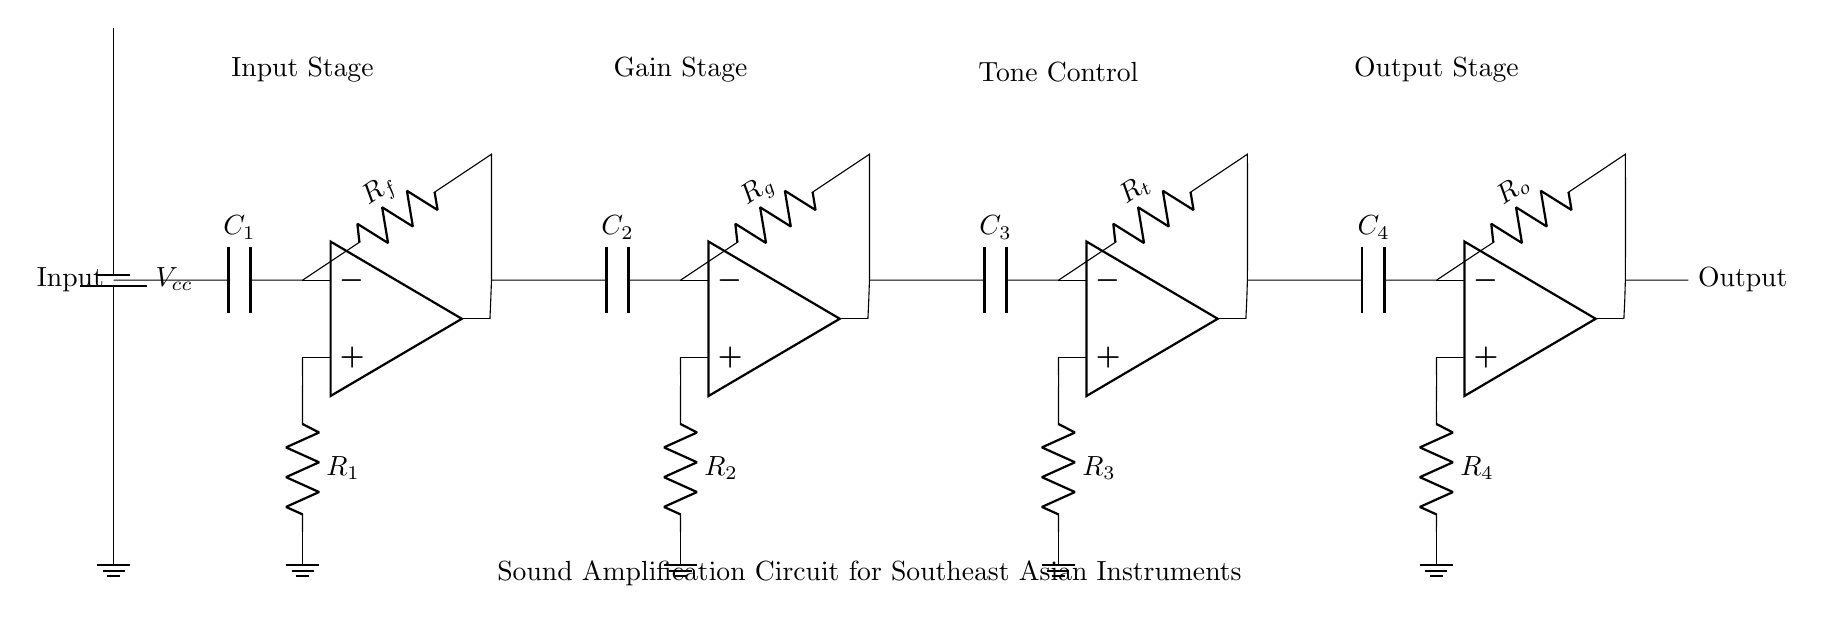What is the total number of operational amplifiers used in this circuit? There are four operational amplifiers present in the circuit diagram, as indicated by the four op amp symbols shown.
Answer: Four What type of capacitor is connected at the input stage? A capacitor labeled C1 is connected directly in line with the input stage, indicating it is the first capacitor in the series for the signal path.
Answer: C1 What is the role of resistor R_f in this circuit? Resistor R_f is connected in the feedback loop of the first operational amplifier, which allows for gain control and stabilizes the amplifier's output by controlling the feedback from the output to the inverting input of the op amp.
Answer: Gain control How many stages are there in the sound amplification circuit? The circuit consists of four distinct stages: Input, Gain, Tone Control, and Output, each serving different functions in processing the sound signal.
Answer: Four What component is used for tone control in this circuit? The tone control stage includes a specific resistor marked R_t in connection with an operational amplifier, which helps adjust the tonal quality of the amplified sound.
Answer: R_t Which stage directly affects the final output of the audio signal? The output stage, which contains the operational amplifier op amp4 and the capacitor C4, is the stage that directly affects the final audio output before it is delivered to the speakers or external devices.
Answer: Output stage What is the power supply voltage labeled in this circuit? The circuit diagram indicates a battery labeled V_cc providing the voltage supply for the entire circuit, which powers the operational amplifiers and other components.
Answer: V_cc 